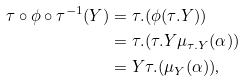Convert formula to latex. <formula><loc_0><loc_0><loc_500><loc_500>\tau \circ \phi \circ \tau ^ { - 1 } ( Y ) & = \tau . ( \phi ( \tau . Y ) ) \\ & = \tau . ( \tau . Y \mu _ { \tau . Y } ( \alpha ) ) \\ & = Y \tau . ( \mu _ { Y } ( \alpha ) ) \text {,}</formula> 